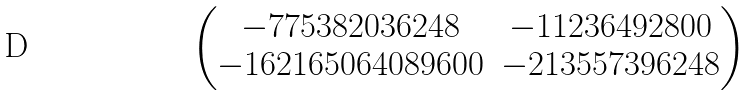<formula> <loc_0><loc_0><loc_500><loc_500>\begin{pmatrix} - 7 7 5 3 8 2 0 3 6 2 4 8 & - 1 1 2 3 6 4 9 2 8 0 0 \\ - 1 6 2 1 6 5 0 6 4 0 8 9 6 0 0 & - 2 1 3 5 5 7 3 9 6 2 4 8 \end{pmatrix}</formula> 